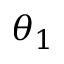<formula> <loc_0><loc_0><loc_500><loc_500>\theta _ { 1 }</formula> 